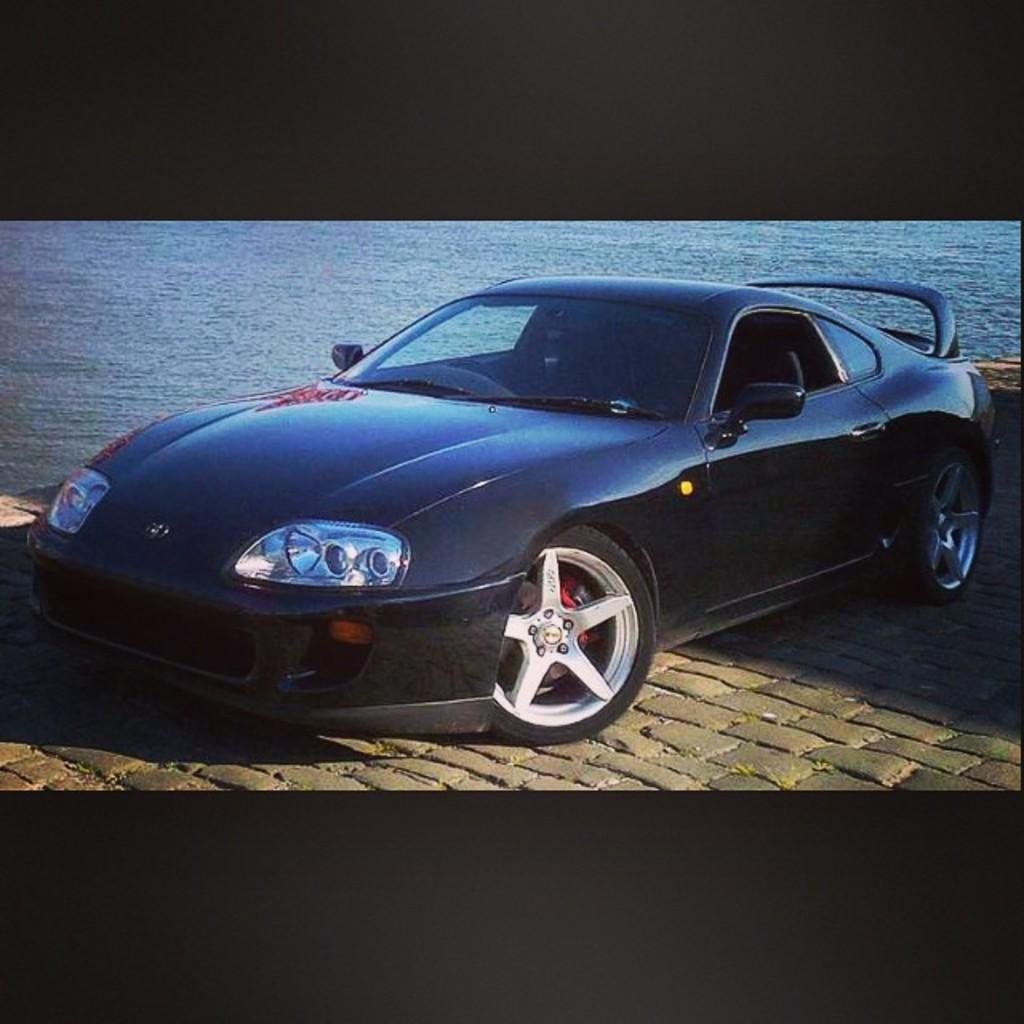How would you summarize this image in a sentence or two? In this image I can see a black colour car in the front and in the background I can see water. 